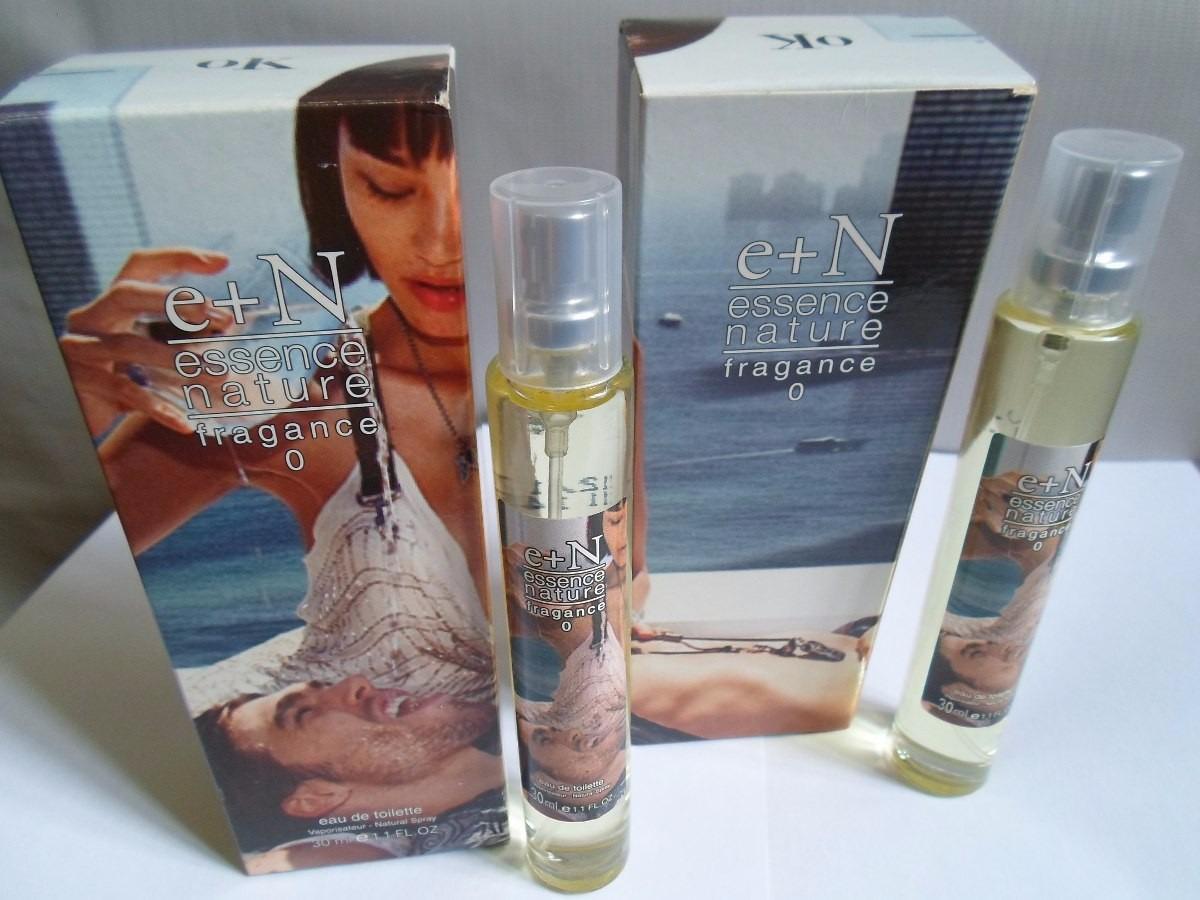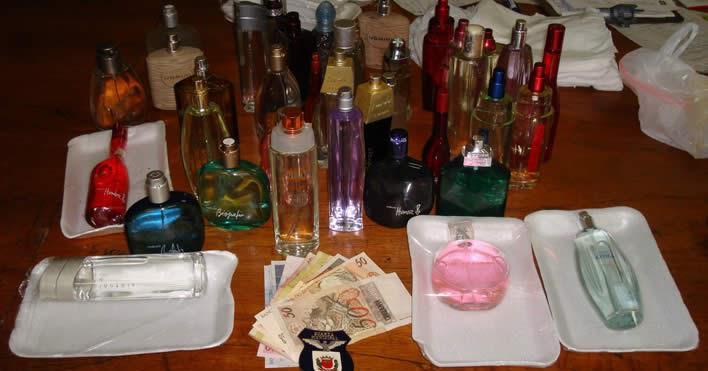The first image is the image on the left, the second image is the image on the right. Examine the images to the left and right. Is the description "In one image, a single slender spray bottle stands to the left of a box with a woman's face on it." accurate? Answer yes or no. No. The first image is the image on the left, the second image is the image on the right. Examine the images to the left and right. Is the description "The lone box of 'essence of nature' features half of a female face." accurate? Answer yes or no. No. The first image is the image on the left, the second image is the image on the right. Assess this claim about the two images: "An image shows a single row of at least five upright boxes standing on a shiny surface.". Correct or not? Answer yes or no. No. The first image is the image on the left, the second image is the image on the right. Assess this claim about the two images: "The right image contains one slim cylinder perfume bottle that is to the left of its packaging case.". Correct or not? Answer yes or no. No. 